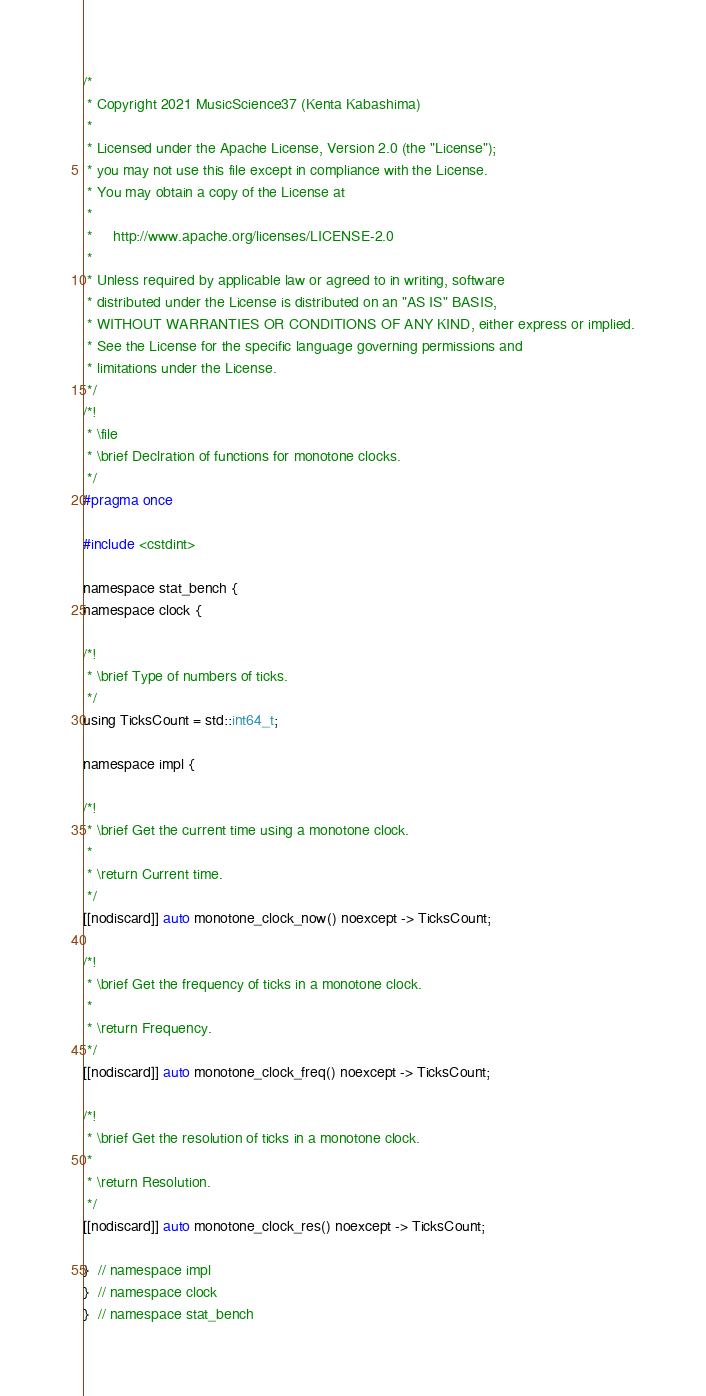<code> <loc_0><loc_0><loc_500><loc_500><_C_>/*
 * Copyright 2021 MusicScience37 (Kenta Kabashima)
 *
 * Licensed under the Apache License, Version 2.0 (the "License");
 * you may not use this file except in compliance with the License.
 * You may obtain a copy of the License at
 *
 *     http://www.apache.org/licenses/LICENSE-2.0
 *
 * Unless required by applicable law or agreed to in writing, software
 * distributed under the License is distributed on an "AS IS" BASIS,
 * WITHOUT WARRANTIES OR CONDITIONS OF ANY KIND, either express or implied.
 * See the License for the specific language governing permissions and
 * limitations under the License.
 */
/*!
 * \file
 * \brief Declration of functions for monotone clocks.
 */
#pragma once

#include <cstdint>

namespace stat_bench {
namespace clock {

/*!
 * \brief Type of numbers of ticks.
 */
using TicksCount = std::int64_t;

namespace impl {

/*!
 * \brief Get the current time using a monotone clock.
 *
 * \return Current time.
 */
[[nodiscard]] auto monotone_clock_now() noexcept -> TicksCount;

/*!
 * \brief Get the frequency of ticks in a monotone clock.
 *
 * \return Frequency.
 */
[[nodiscard]] auto monotone_clock_freq() noexcept -> TicksCount;

/*!
 * \brief Get the resolution of ticks in a monotone clock.
 *
 * \return Resolution.
 */
[[nodiscard]] auto monotone_clock_res() noexcept -> TicksCount;

}  // namespace impl
}  // namespace clock
}  // namespace stat_bench
</code> 